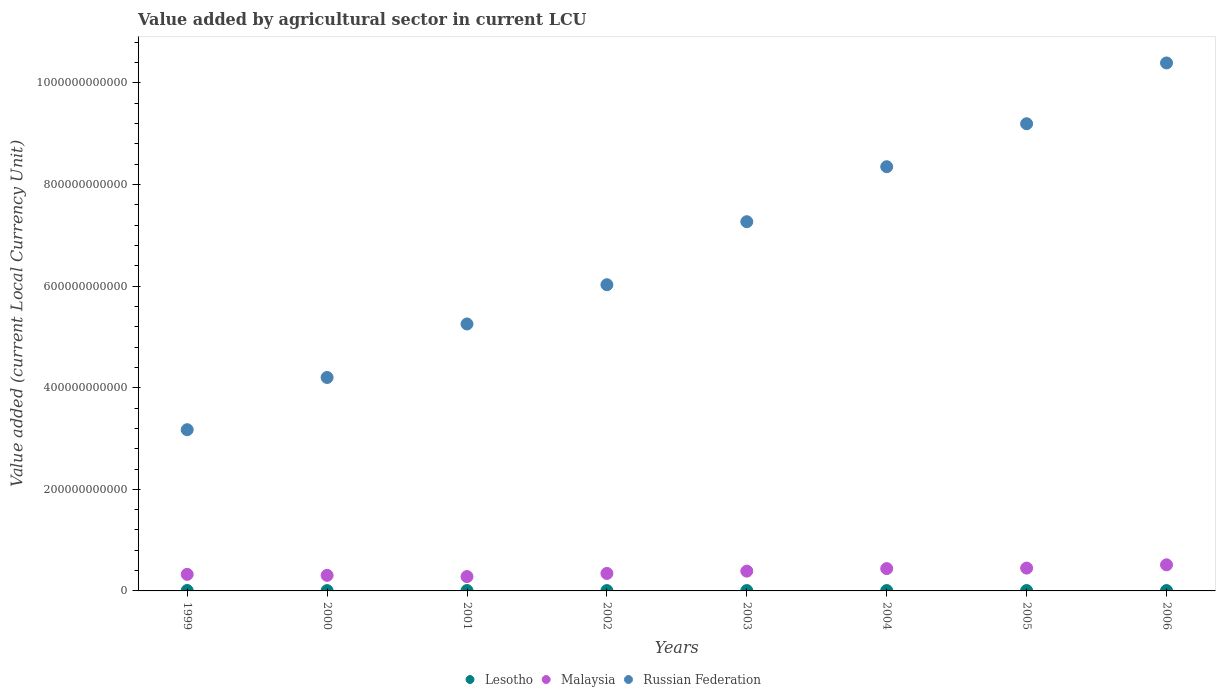Is the number of dotlines equal to the number of legend labels?
Give a very brief answer. Yes. What is the value added by agricultural sector in Russian Federation in 2005?
Offer a very short reply. 9.20e+11. Across all years, what is the maximum value added by agricultural sector in Russian Federation?
Give a very brief answer. 1.04e+12. Across all years, what is the minimum value added by agricultural sector in Malaysia?
Your answer should be compact. 2.82e+1. In which year was the value added by agricultural sector in Russian Federation maximum?
Provide a short and direct response. 2006. In which year was the value added by agricultural sector in Russian Federation minimum?
Your answer should be compact. 1999. What is the total value added by agricultural sector in Lesotho in the graph?
Your answer should be very brief. 5.61e+09. What is the difference between the value added by agricultural sector in Russian Federation in 2002 and that in 2003?
Provide a short and direct response. -1.24e+11. What is the difference between the value added by agricultural sector in Malaysia in 2002 and the value added by agricultural sector in Russian Federation in 2003?
Offer a very short reply. -6.92e+11. What is the average value added by agricultural sector in Lesotho per year?
Your answer should be compact. 7.02e+08. In the year 2005, what is the difference between the value added by agricultural sector in Malaysia and value added by agricultural sector in Lesotho?
Ensure brevity in your answer.  4.42e+1. In how many years, is the value added by agricultural sector in Lesotho greater than 160000000000 LCU?
Make the answer very short. 0. What is the ratio of the value added by agricultural sector in Malaysia in 2004 to that in 2005?
Your response must be concise. 0.98. What is the difference between the highest and the second highest value added by agricultural sector in Malaysia?
Offer a terse response. 6.47e+09. What is the difference between the highest and the lowest value added by agricultural sector in Russian Federation?
Your response must be concise. 7.22e+11. Does the value added by agricultural sector in Russian Federation monotonically increase over the years?
Keep it short and to the point. Yes. Is the value added by agricultural sector in Malaysia strictly greater than the value added by agricultural sector in Russian Federation over the years?
Provide a succinct answer. No. What is the difference between two consecutive major ticks on the Y-axis?
Your answer should be very brief. 2.00e+11. Does the graph contain any zero values?
Give a very brief answer. No. How many legend labels are there?
Provide a short and direct response. 3. What is the title of the graph?
Your answer should be compact. Value added by agricultural sector in current LCU. Does "Austria" appear as one of the legend labels in the graph?
Your answer should be very brief. No. What is the label or title of the X-axis?
Make the answer very short. Years. What is the label or title of the Y-axis?
Provide a short and direct response. Value added (current Local Currency Unit). What is the Value added (current Local Currency Unit) in Lesotho in 1999?
Offer a very short reply. 8.32e+08. What is the Value added (current Local Currency Unit) in Malaysia in 1999?
Provide a succinct answer. 3.26e+1. What is the Value added (current Local Currency Unit) of Russian Federation in 1999?
Make the answer very short. 3.17e+11. What is the Value added (current Local Currency Unit) in Lesotho in 2000?
Provide a short and direct response. 5.98e+08. What is the Value added (current Local Currency Unit) in Malaysia in 2000?
Make the answer very short. 3.06e+1. What is the Value added (current Local Currency Unit) of Russian Federation in 2000?
Offer a very short reply. 4.20e+11. What is the Value added (current Local Currency Unit) in Lesotho in 2001?
Give a very brief answer. 7.31e+08. What is the Value added (current Local Currency Unit) in Malaysia in 2001?
Keep it short and to the point. 2.82e+1. What is the Value added (current Local Currency Unit) of Russian Federation in 2001?
Ensure brevity in your answer.  5.26e+11. What is the Value added (current Local Currency Unit) of Lesotho in 2002?
Your response must be concise. 6.50e+08. What is the Value added (current Local Currency Unit) of Malaysia in 2002?
Your response must be concise. 3.44e+1. What is the Value added (current Local Currency Unit) of Russian Federation in 2002?
Offer a terse response. 6.03e+11. What is the Value added (current Local Currency Unit) of Lesotho in 2003?
Make the answer very short. 6.71e+08. What is the Value added (current Local Currency Unit) in Malaysia in 2003?
Give a very brief answer. 3.90e+1. What is the Value added (current Local Currency Unit) of Russian Federation in 2003?
Your response must be concise. 7.27e+11. What is the Value added (current Local Currency Unit) in Lesotho in 2004?
Keep it short and to the point. 7.02e+08. What is the Value added (current Local Currency Unit) of Malaysia in 2004?
Offer a terse response. 4.40e+1. What is the Value added (current Local Currency Unit) of Russian Federation in 2004?
Your answer should be very brief. 8.35e+11. What is the Value added (current Local Currency Unit) of Lesotho in 2005?
Provide a succinct answer. 7.21e+08. What is the Value added (current Local Currency Unit) in Malaysia in 2005?
Your answer should be very brief. 4.49e+1. What is the Value added (current Local Currency Unit) in Russian Federation in 2005?
Your answer should be compact. 9.20e+11. What is the Value added (current Local Currency Unit) of Lesotho in 2006?
Ensure brevity in your answer.  7.09e+08. What is the Value added (current Local Currency Unit) in Malaysia in 2006?
Give a very brief answer. 5.14e+1. What is the Value added (current Local Currency Unit) of Russian Federation in 2006?
Keep it short and to the point. 1.04e+12. Across all years, what is the maximum Value added (current Local Currency Unit) in Lesotho?
Give a very brief answer. 8.32e+08. Across all years, what is the maximum Value added (current Local Currency Unit) of Malaysia?
Make the answer very short. 5.14e+1. Across all years, what is the maximum Value added (current Local Currency Unit) in Russian Federation?
Provide a succinct answer. 1.04e+12. Across all years, what is the minimum Value added (current Local Currency Unit) of Lesotho?
Your response must be concise. 5.98e+08. Across all years, what is the minimum Value added (current Local Currency Unit) of Malaysia?
Keep it short and to the point. 2.82e+1. Across all years, what is the minimum Value added (current Local Currency Unit) of Russian Federation?
Provide a succinct answer. 3.17e+11. What is the total Value added (current Local Currency Unit) of Lesotho in the graph?
Your answer should be compact. 5.61e+09. What is the total Value added (current Local Currency Unit) in Malaysia in the graph?
Provide a short and direct response. 3.05e+11. What is the total Value added (current Local Currency Unit) of Russian Federation in the graph?
Provide a succinct answer. 5.39e+12. What is the difference between the Value added (current Local Currency Unit) in Lesotho in 1999 and that in 2000?
Your answer should be compact. 2.34e+08. What is the difference between the Value added (current Local Currency Unit) in Malaysia in 1999 and that in 2000?
Offer a very short reply. 1.96e+09. What is the difference between the Value added (current Local Currency Unit) in Russian Federation in 1999 and that in 2000?
Your response must be concise. -1.03e+11. What is the difference between the Value added (current Local Currency Unit) of Lesotho in 1999 and that in 2001?
Your answer should be very brief. 1.01e+08. What is the difference between the Value added (current Local Currency Unit) in Malaysia in 1999 and that in 2001?
Your answer should be compact. 4.36e+09. What is the difference between the Value added (current Local Currency Unit) of Russian Federation in 1999 and that in 2001?
Your response must be concise. -2.08e+11. What is the difference between the Value added (current Local Currency Unit) of Lesotho in 1999 and that in 2002?
Provide a succinct answer. 1.82e+08. What is the difference between the Value added (current Local Currency Unit) in Malaysia in 1999 and that in 2002?
Keep it short and to the point. -1.82e+09. What is the difference between the Value added (current Local Currency Unit) of Russian Federation in 1999 and that in 2002?
Your response must be concise. -2.85e+11. What is the difference between the Value added (current Local Currency Unit) in Lesotho in 1999 and that in 2003?
Keep it short and to the point. 1.61e+08. What is the difference between the Value added (current Local Currency Unit) in Malaysia in 1999 and that in 2003?
Give a very brief answer. -6.36e+09. What is the difference between the Value added (current Local Currency Unit) in Russian Federation in 1999 and that in 2003?
Provide a short and direct response. -4.09e+11. What is the difference between the Value added (current Local Currency Unit) of Lesotho in 1999 and that in 2004?
Your answer should be compact. 1.30e+08. What is the difference between the Value added (current Local Currency Unit) of Malaysia in 1999 and that in 2004?
Your response must be concise. -1.13e+1. What is the difference between the Value added (current Local Currency Unit) of Russian Federation in 1999 and that in 2004?
Keep it short and to the point. -5.18e+11. What is the difference between the Value added (current Local Currency Unit) of Lesotho in 1999 and that in 2005?
Make the answer very short. 1.11e+08. What is the difference between the Value added (current Local Currency Unit) of Malaysia in 1999 and that in 2005?
Provide a short and direct response. -1.23e+1. What is the difference between the Value added (current Local Currency Unit) in Russian Federation in 1999 and that in 2005?
Your answer should be compact. -6.02e+11. What is the difference between the Value added (current Local Currency Unit) of Lesotho in 1999 and that in 2006?
Offer a very short reply. 1.23e+08. What is the difference between the Value added (current Local Currency Unit) in Malaysia in 1999 and that in 2006?
Your answer should be compact. -1.88e+1. What is the difference between the Value added (current Local Currency Unit) of Russian Federation in 1999 and that in 2006?
Provide a succinct answer. -7.22e+11. What is the difference between the Value added (current Local Currency Unit) in Lesotho in 2000 and that in 2001?
Give a very brief answer. -1.33e+08. What is the difference between the Value added (current Local Currency Unit) in Malaysia in 2000 and that in 2001?
Provide a succinct answer. 2.40e+09. What is the difference between the Value added (current Local Currency Unit) in Russian Federation in 2000 and that in 2001?
Your answer should be very brief. -1.05e+11. What is the difference between the Value added (current Local Currency Unit) in Lesotho in 2000 and that in 2002?
Offer a terse response. -5.16e+07. What is the difference between the Value added (current Local Currency Unit) in Malaysia in 2000 and that in 2002?
Provide a short and direct response. -3.78e+09. What is the difference between the Value added (current Local Currency Unit) of Russian Federation in 2000 and that in 2002?
Keep it short and to the point. -1.83e+11. What is the difference between the Value added (current Local Currency Unit) of Lesotho in 2000 and that in 2003?
Give a very brief answer. -7.26e+07. What is the difference between the Value added (current Local Currency Unit) in Malaysia in 2000 and that in 2003?
Keep it short and to the point. -8.32e+09. What is the difference between the Value added (current Local Currency Unit) in Russian Federation in 2000 and that in 2003?
Offer a terse response. -3.07e+11. What is the difference between the Value added (current Local Currency Unit) in Lesotho in 2000 and that in 2004?
Your response must be concise. -1.04e+08. What is the difference between the Value added (current Local Currency Unit) of Malaysia in 2000 and that in 2004?
Provide a short and direct response. -1.33e+1. What is the difference between the Value added (current Local Currency Unit) of Russian Federation in 2000 and that in 2004?
Ensure brevity in your answer.  -4.15e+11. What is the difference between the Value added (current Local Currency Unit) in Lesotho in 2000 and that in 2005?
Offer a very short reply. -1.23e+08. What is the difference between the Value added (current Local Currency Unit) in Malaysia in 2000 and that in 2005?
Give a very brief answer. -1.43e+1. What is the difference between the Value added (current Local Currency Unit) in Russian Federation in 2000 and that in 2005?
Keep it short and to the point. -4.99e+11. What is the difference between the Value added (current Local Currency Unit) in Lesotho in 2000 and that in 2006?
Your answer should be compact. -1.10e+08. What is the difference between the Value added (current Local Currency Unit) of Malaysia in 2000 and that in 2006?
Ensure brevity in your answer.  -2.07e+1. What is the difference between the Value added (current Local Currency Unit) in Russian Federation in 2000 and that in 2006?
Offer a very short reply. -6.19e+11. What is the difference between the Value added (current Local Currency Unit) in Lesotho in 2001 and that in 2002?
Your response must be concise. 8.10e+07. What is the difference between the Value added (current Local Currency Unit) in Malaysia in 2001 and that in 2002?
Make the answer very short. -6.19e+09. What is the difference between the Value added (current Local Currency Unit) in Russian Federation in 2001 and that in 2002?
Keep it short and to the point. -7.73e+1. What is the difference between the Value added (current Local Currency Unit) in Lesotho in 2001 and that in 2003?
Ensure brevity in your answer.  6.00e+07. What is the difference between the Value added (current Local Currency Unit) of Malaysia in 2001 and that in 2003?
Your response must be concise. -1.07e+1. What is the difference between the Value added (current Local Currency Unit) of Russian Federation in 2001 and that in 2003?
Your answer should be very brief. -2.01e+11. What is the difference between the Value added (current Local Currency Unit) in Lesotho in 2001 and that in 2004?
Provide a short and direct response. 2.90e+07. What is the difference between the Value added (current Local Currency Unit) of Malaysia in 2001 and that in 2004?
Your response must be concise. -1.57e+1. What is the difference between the Value added (current Local Currency Unit) of Russian Federation in 2001 and that in 2004?
Keep it short and to the point. -3.10e+11. What is the difference between the Value added (current Local Currency Unit) in Lesotho in 2001 and that in 2005?
Keep it short and to the point. 9.99e+06. What is the difference between the Value added (current Local Currency Unit) in Malaysia in 2001 and that in 2005?
Provide a short and direct response. -1.67e+1. What is the difference between the Value added (current Local Currency Unit) of Russian Federation in 2001 and that in 2005?
Keep it short and to the point. -3.94e+11. What is the difference between the Value added (current Local Currency Unit) of Lesotho in 2001 and that in 2006?
Give a very brief answer. 2.23e+07. What is the difference between the Value added (current Local Currency Unit) in Malaysia in 2001 and that in 2006?
Your answer should be compact. -2.31e+1. What is the difference between the Value added (current Local Currency Unit) in Russian Federation in 2001 and that in 2006?
Offer a very short reply. -5.14e+11. What is the difference between the Value added (current Local Currency Unit) in Lesotho in 2002 and that in 2003?
Provide a short and direct response. -2.10e+07. What is the difference between the Value added (current Local Currency Unit) in Malaysia in 2002 and that in 2003?
Your answer should be very brief. -4.54e+09. What is the difference between the Value added (current Local Currency Unit) of Russian Federation in 2002 and that in 2003?
Provide a succinct answer. -1.24e+11. What is the difference between the Value added (current Local Currency Unit) in Lesotho in 2002 and that in 2004?
Offer a very short reply. -5.20e+07. What is the difference between the Value added (current Local Currency Unit) of Malaysia in 2002 and that in 2004?
Provide a short and direct response. -9.52e+09. What is the difference between the Value added (current Local Currency Unit) of Russian Federation in 2002 and that in 2004?
Ensure brevity in your answer.  -2.32e+11. What is the difference between the Value added (current Local Currency Unit) in Lesotho in 2002 and that in 2005?
Make the answer very short. -7.10e+07. What is the difference between the Value added (current Local Currency Unit) of Malaysia in 2002 and that in 2005?
Your answer should be compact. -1.05e+1. What is the difference between the Value added (current Local Currency Unit) in Russian Federation in 2002 and that in 2005?
Give a very brief answer. -3.17e+11. What is the difference between the Value added (current Local Currency Unit) in Lesotho in 2002 and that in 2006?
Provide a short and direct response. -5.87e+07. What is the difference between the Value added (current Local Currency Unit) of Malaysia in 2002 and that in 2006?
Give a very brief answer. -1.70e+1. What is the difference between the Value added (current Local Currency Unit) in Russian Federation in 2002 and that in 2006?
Offer a very short reply. -4.37e+11. What is the difference between the Value added (current Local Currency Unit) in Lesotho in 2003 and that in 2004?
Offer a terse response. -3.10e+07. What is the difference between the Value added (current Local Currency Unit) in Malaysia in 2003 and that in 2004?
Keep it short and to the point. -4.98e+09. What is the difference between the Value added (current Local Currency Unit) of Russian Federation in 2003 and that in 2004?
Provide a succinct answer. -1.08e+11. What is the difference between the Value added (current Local Currency Unit) in Lesotho in 2003 and that in 2005?
Provide a short and direct response. -5.00e+07. What is the difference between the Value added (current Local Currency Unit) in Malaysia in 2003 and that in 2005?
Offer a terse response. -5.94e+09. What is the difference between the Value added (current Local Currency Unit) in Russian Federation in 2003 and that in 2005?
Offer a very short reply. -1.93e+11. What is the difference between the Value added (current Local Currency Unit) of Lesotho in 2003 and that in 2006?
Your answer should be very brief. -3.77e+07. What is the difference between the Value added (current Local Currency Unit) in Malaysia in 2003 and that in 2006?
Offer a terse response. -1.24e+1. What is the difference between the Value added (current Local Currency Unit) in Russian Federation in 2003 and that in 2006?
Provide a succinct answer. -3.13e+11. What is the difference between the Value added (current Local Currency Unit) in Lesotho in 2004 and that in 2005?
Keep it short and to the point. -1.90e+07. What is the difference between the Value added (current Local Currency Unit) of Malaysia in 2004 and that in 2005?
Give a very brief answer. -9.62e+08. What is the difference between the Value added (current Local Currency Unit) in Russian Federation in 2004 and that in 2005?
Give a very brief answer. -8.46e+1. What is the difference between the Value added (current Local Currency Unit) in Lesotho in 2004 and that in 2006?
Your answer should be very brief. -6.68e+06. What is the difference between the Value added (current Local Currency Unit) in Malaysia in 2004 and that in 2006?
Offer a very short reply. -7.43e+09. What is the difference between the Value added (current Local Currency Unit) in Russian Federation in 2004 and that in 2006?
Ensure brevity in your answer.  -2.04e+11. What is the difference between the Value added (current Local Currency Unit) in Lesotho in 2005 and that in 2006?
Make the answer very short. 1.23e+07. What is the difference between the Value added (current Local Currency Unit) in Malaysia in 2005 and that in 2006?
Offer a terse response. -6.47e+09. What is the difference between the Value added (current Local Currency Unit) in Russian Federation in 2005 and that in 2006?
Provide a succinct answer. -1.20e+11. What is the difference between the Value added (current Local Currency Unit) of Lesotho in 1999 and the Value added (current Local Currency Unit) of Malaysia in 2000?
Keep it short and to the point. -2.98e+1. What is the difference between the Value added (current Local Currency Unit) of Lesotho in 1999 and the Value added (current Local Currency Unit) of Russian Federation in 2000?
Make the answer very short. -4.19e+11. What is the difference between the Value added (current Local Currency Unit) of Malaysia in 1999 and the Value added (current Local Currency Unit) of Russian Federation in 2000?
Your answer should be compact. -3.88e+11. What is the difference between the Value added (current Local Currency Unit) in Lesotho in 1999 and the Value added (current Local Currency Unit) in Malaysia in 2001?
Ensure brevity in your answer.  -2.74e+1. What is the difference between the Value added (current Local Currency Unit) of Lesotho in 1999 and the Value added (current Local Currency Unit) of Russian Federation in 2001?
Your answer should be very brief. -5.25e+11. What is the difference between the Value added (current Local Currency Unit) in Malaysia in 1999 and the Value added (current Local Currency Unit) in Russian Federation in 2001?
Ensure brevity in your answer.  -4.93e+11. What is the difference between the Value added (current Local Currency Unit) of Lesotho in 1999 and the Value added (current Local Currency Unit) of Malaysia in 2002?
Offer a terse response. -3.36e+1. What is the difference between the Value added (current Local Currency Unit) of Lesotho in 1999 and the Value added (current Local Currency Unit) of Russian Federation in 2002?
Provide a short and direct response. -6.02e+11. What is the difference between the Value added (current Local Currency Unit) in Malaysia in 1999 and the Value added (current Local Currency Unit) in Russian Federation in 2002?
Keep it short and to the point. -5.70e+11. What is the difference between the Value added (current Local Currency Unit) of Lesotho in 1999 and the Value added (current Local Currency Unit) of Malaysia in 2003?
Keep it short and to the point. -3.81e+1. What is the difference between the Value added (current Local Currency Unit) of Lesotho in 1999 and the Value added (current Local Currency Unit) of Russian Federation in 2003?
Provide a short and direct response. -7.26e+11. What is the difference between the Value added (current Local Currency Unit) in Malaysia in 1999 and the Value added (current Local Currency Unit) in Russian Federation in 2003?
Your answer should be very brief. -6.94e+11. What is the difference between the Value added (current Local Currency Unit) of Lesotho in 1999 and the Value added (current Local Currency Unit) of Malaysia in 2004?
Provide a short and direct response. -4.31e+1. What is the difference between the Value added (current Local Currency Unit) of Lesotho in 1999 and the Value added (current Local Currency Unit) of Russian Federation in 2004?
Give a very brief answer. -8.34e+11. What is the difference between the Value added (current Local Currency Unit) of Malaysia in 1999 and the Value added (current Local Currency Unit) of Russian Federation in 2004?
Give a very brief answer. -8.02e+11. What is the difference between the Value added (current Local Currency Unit) in Lesotho in 1999 and the Value added (current Local Currency Unit) in Malaysia in 2005?
Keep it short and to the point. -4.41e+1. What is the difference between the Value added (current Local Currency Unit) of Lesotho in 1999 and the Value added (current Local Currency Unit) of Russian Federation in 2005?
Make the answer very short. -9.19e+11. What is the difference between the Value added (current Local Currency Unit) of Malaysia in 1999 and the Value added (current Local Currency Unit) of Russian Federation in 2005?
Provide a short and direct response. -8.87e+11. What is the difference between the Value added (current Local Currency Unit) in Lesotho in 1999 and the Value added (current Local Currency Unit) in Malaysia in 2006?
Offer a very short reply. -5.06e+1. What is the difference between the Value added (current Local Currency Unit) of Lesotho in 1999 and the Value added (current Local Currency Unit) of Russian Federation in 2006?
Your answer should be very brief. -1.04e+12. What is the difference between the Value added (current Local Currency Unit) in Malaysia in 1999 and the Value added (current Local Currency Unit) in Russian Federation in 2006?
Provide a short and direct response. -1.01e+12. What is the difference between the Value added (current Local Currency Unit) in Lesotho in 2000 and the Value added (current Local Currency Unit) in Malaysia in 2001?
Provide a succinct answer. -2.76e+1. What is the difference between the Value added (current Local Currency Unit) of Lesotho in 2000 and the Value added (current Local Currency Unit) of Russian Federation in 2001?
Ensure brevity in your answer.  -5.25e+11. What is the difference between the Value added (current Local Currency Unit) in Malaysia in 2000 and the Value added (current Local Currency Unit) in Russian Federation in 2001?
Your answer should be compact. -4.95e+11. What is the difference between the Value added (current Local Currency Unit) in Lesotho in 2000 and the Value added (current Local Currency Unit) in Malaysia in 2002?
Keep it short and to the point. -3.38e+1. What is the difference between the Value added (current Local Currency Unit) in Lesotho in 2000 and the Value added (current Local Currency Unit) in Russian Federation in 2002?
Provide a short and direct response. -6.02e+11. What is the difference between the Value added (current Local Currency Unit) of Malaysia in 2000 and the Value added (current Local Currency Unit) of Russian Federation in 2002?
Your answer should be very brief. -5.72e+11. What is the difference between the Value added (current Local Currency Unit) in Lesotho in 2000 and the Value added (current Local Currency Unit) in Malaysia in 2003?
Ensure brevity in your answer.  -3.84e+1. What is the difference between the Value added (current Local Currency Unit) in Lesotho in 2000 and the Value added (current Local Currency Unit) in Russian Federation in 2003?
Make the answer very short. -7.26e+11. What is the difference between the Value added (current Local Currency Unit) of Malaysia in 2000 and the Value added (current Local Currency Unit) of Russian Federation in 2003?
Keep it short and to the point. -6.96e+11. What is the difference between the Value added (current Local Currency Unit) of Lesotho in 2000 and the Value added (current Local Currency Unit) of Malaysia in 2004?
Give a very brief answer. -4.34e+1. What is the difference between the Value added (current Local Currency Unit) in Lesotho in 2000 and the Value added (current Local Currency Unit) in Russian Federation in 2004?
Provide a short and direct response. -8.34e+11. What is the difference between the Value added (current Local Currency Unit) in Malaysia in 2000 and the Value added (current Local Currency Unit) in Russian Federation in 2004?
Ensure brevity in your answer.  -8.04e+11. What is the difference between the Value added (current Local Currency Unit) in Lesotho in 2000 and the Value added (current Local Currency Unit) in Malaysia in 2005?
Provide a short and direct response. -4.43e+1. What is the difference between the Value added (current Local Currency Unit) in Lesotho in 2000 and the Value added (current Local Currency Unit) in Russian Federation in 2005?
Offer a terse response. -9.19e+11. What is the difference between the Value added (current Local Currency Unit) in Malaysia in 2000 and the Value added (current Local Currency Unit) in Russian Federation in 2005?
Provide a succinct answer. -8.89e+11. What is the difference between the Value added (current Local Currency Unit) of Lesotho in 2000 and the Value added (current Local Currency Unit) of Malaysia in 2006?
Provide a succinct answer. -5.08e+1. What is the difference between the Value added (current Local Currency Unit) of Lesotho in 2000 and the Value added (current Local Currency Unit) of Russian Federation in 2006?
Ensure brevity in your answer.  -1.04e+12. What is the difference between the Value added (current Local Currency Unit) of Malaysia in 2000 and the Value added (current Local Currency Unit) of Russian Federation in 2006?
Ensure brevity in your answer.  -1.01e+12. What is the difference between the Value added (current Local Currency Unit) of Lesotho in 2001 and the Value added (current Local Currency Unit) of Malaysia in 2002?
Offer a very short reply. -3.37e+1. What is the difference between the Value added (current Local Currency Unit) of Lesotho in 2001 and the Value added (current Local Currency Unit) of Russian Federation in 2002?
Your answer should be compact. -6.02e+11. What is the difference between the Value added (current Local Currency Unit) of Malaysia in 2001 and the Value added (current Local Currency Unit) of Russian Federation in 2002?
Offer a very short reply. -5.75e+11. What is the difference between the Value added (current Local Currency Unit) in Lesotho in 2001 and the Value added (current Local Currency Unit) in Malaysia in 2003?
Your answer should be very brief. -3.82e+1. What is the difference between the Value added (current Local Currency Unit) in Lesotho in 2001 and the Value added (current Local Currency Unit) in Russian Federation in 2003?
Give a very brief answer. -7.26e+11. What is the difference between the Value added (current Local Currency Unit) of Malaysia in 2001 and the Value added (current Local Currency Unit) of Russian Federation in 2003?
Provide a short and direct response. -6.99e+11. What is the difference between the Value added (current Local Currency Unit) of Lesotho in 2001 and the Value added (current Local Currency Unit) of Malaysia in 2004?
Ensure brevity in your answer.  -4.32e+1. What is the difference between the Value added (current Local Currency Unit) in Lesotho in 2001 and the Value added (current Local Currency Unit) in Russian Federation in 2004?
Ensure brevity in your answer.  -8.34e+11. What is the difference between the Value added (current Local Currency Unit) in Malaysia in 2001 and the Value added (current Local Currency Unit) in Russian Federation in 2004?
Your response must be concise. -8.07e+11. What is the difference between the Value added (current Local Currency Unit) in Lesotho in 2001 and the Value added (current Local Currency Unit) in Malaysia in 2005?
Provide a short and direct response. -4.42e+1. What is the difference between the Value added (current Local Currency Unit) in Lesotho in 2001 and the Value added (current Local Currency Unit) in Russian Federation in 2005?
Make the answer very short. -9.19e+11. What is the difference between the Value added (current Local Currency Unit) in Malaysia in 2001 and the Value added (current Local Currency Unit) in Russian Federation in 2005?
Your answer should be very brief. -8.91e+11. What is the difference between the Value added (current Local Currency Unit) in Lesotho in 2001 and the Value added (current Local Currency Unit) in Malaysia in 2006?
Offer a terse response. -5.07e+1. What is the difference between the Value added (current Local Currency Unit) of Lesotho in 2001 and the Value added (current Local Currency Unit) of Russian Federation in 2006?
Provide a succinct answer. -1.04e+12. What is the difference between the Value added (current Local Currency Unit) of Malaysia in 2001 and the Value added (current Local Currency Unit) of Russian Federation in 2006?
Offer a very short reply. -1.01e+12. What is the difference between the Value added (current Local Currency Unit) in Lesotho in 2002 and the Value added (current Local Currency Unit) in Malaysia in 2003?
Offer a terse response. -3.83e+1. What is the difference between the Value added (current Local Currency Unit) of Lesotho in 2002 and the Value added (current Local Currency Unit) of Russian Federation in 2003?
Give a very brief answer. -7.26e+11. What is the difference between the Value added (current Local Currency Unit) in Malaysia in 2002 and the Value added (current Local Currency Unit) in Russian Federation in 2003?
Your answer should be very brief. -6.92e+11. What is the difference between the Value added (current Local Currency Unit) of Lesotho in 2002 and the Value added (current Local Currency Unit) of Malaysia in 2004?
Provide a succinct answer. -4.33e+1. What is the difference between the Value added (current Local Currency Unit) of Lesotho in 2002 and the Value added (current Local Currency Unit) of Russian Federation in 2004?
Provide a succinct answer. -8.34e+11. What is the difference between the Value added (current Local Currency Unit) of Malaysia in 2002 and the Value added (current Local Currency Unit) of Russian Federation in 2004?
Give a very brief answer. -8.01e+11. What is the difference between the Value added (current Local Currency Unit) in Lesotho in 2002 and the Value added (current Local Currency Unit) in Malaysia in 2005?
Your answer should be very brief. -4.43e+1. What is the difference between the Value added (current Local Currency Unit) in Lesotho in 2002 and the Value added (current Local Currency Unit) in Russian Federation in 2005?
Give a very brief answer. -9.19e+11. What is the difference between the Value added (current Local Currency Unit) of Malaysia in 2002 and the Value added (current Local Currency Unit) of Russian Federation in 2005?
Make the answer very short. -8.85e+11. What is the difference between the Value added (current Local Currency Unit) of Lesotho in 2002 and the Value added (current Local Currency Unit) of Malaysia in 2006?
Make the answer very short. -5.07e+1. What is the difference between the Value added (current Local Currency Unit) in Lesotho in 2002 and the Value added (current Local Currency Unit) in Russian Federation in 2006?
Your answer should be compact. -1.04e+12. What is the difference between the Value added (current Local Currency Unit) in Malaysia in 2002 and the Value added (current Local Currency Unit) in Russian Federation in 2006?
Offer a terse response. -1.00e+12. What is the difference between the Value added (current Local Currency Unit) in Lesotho in 2003 and the Value added (current Local Currency Unit) in Malaysia in 2004?
Provide a succinct answer. -4.33e+1. What is the difference between the Value added (current Local Currency Unit) in Lesotho in 2003 and the Value added (current Local Currency Unit) in Russian Federation in 2004?
Offer a terse response. -8.34e+11. What is the difference between the Value added (current Local Currency Unit) in Malaysia in 2003 and the Value added (current Local Currency Unit) in Russian Federation in 2004?
Keep it short and to the point. -7.96e+11. What is the difference between the Value added (current Local Currency Unit) in Lesotho in 2003 and the Value added (current Local Currency Unit) in Malaysia in 2005?
Your answer should be very brief. -4.42e+1. What is the difference between the Value added (current Local Currency Unit) in Lesotho in 2003 and the Value added (current Local Currency Unit) in Russian Federation in 2005?
Provide a succinct answer. -9.19e+11. What is the difference between the Value added (current Local Currency Unit) in Malaysia in 2003 and the Value added (current Local Currency Unit) in Russian Federation in 2005?
Provide a short and direct response. -8.81e+11. What is the difference between the Value added (current Local Currency Unit) of Lesotho in 2003 and the Value added (current Local Currency Unit) of Malaysia in 2006?
Your response must be concise. -5.07e+1. What is the difference between the Value added (current Local Currency Unit) in Lesotho in 2003 and the Value added (current Local Currency Unit) in Russian Federation in 2006?
Provide a short and direct response. -1.04e+12. What is the difference between the Value added (current Local Currency Unit) in Malaysia in 2003 and the Value added (current Local Currency Unit) in Russian Federation in 2006?
Offer a very short reply. -1.00e+12. What is the difference between the Value added (current Local Currency Unit) of Lesotho in 2004 and the Value added (current Local Currency Unit) of Malaysia in 2005?
Your response must be concise. -4.42e+1. What is the difference between the Value added (current Local Currency Unit) in Lesotho in 2004 and the Value added (current Local Currency Unit) in Russian Federation in 2005?
Provide a short and direct response. -9.19e+11. What is the difference between the Value added (current Local Currency Unit) of Malaysia in 2004 and the Value added (current Local Currency Unit) of Russian Federation in 2005?
Offer a terse response. -8.76e+11. What is the difference between the Value added (current Local Currency Unit) of Lesotho in 2004 and the Value added (current Local Currency Unit) of Malaysia in 2006?
Keep it short and to the point. -5.07e+1. What is the difference between the Value added (current Local Currency Unit) of Lesotho in 2004 and the Value added (current Local Currency Unit) of Russian Federation in 2006?
Ensure brevity in your answer.  -1.04e+12. What is the difference between the Value added (current Local Currency Unit) of Malaysia in 2004 and the Value added (current Local Currency Unit) of Russian Federation in 2006?
Your response must be concise. -9.95e+11. What is the difference between the Value added (current Local Currency Unit) of Lesotho in 2005 and the Value added (current Local Currency Unit) of Malaysia in 2006?
Give a very brief answer. -5.07e+1. What is the difference between the Value added (current Local Currency Unit) of Lesotho in 2005 and the Value added (current Local Currency Unit) of Russian Federation in 2006?
Provide a succinct answer. -1.04e+12. What is the difference between the Value added (current Local Currency Unit) of Malaysia in 2005 and the Value added (current Local Currency Unit) of Russian Federation in 2006?
Your answer should be very brief. -9.94e+11. What is the average Value added (current Local Currency Unit) of Lesotho per year?
Keep it short and to the point. 7.02e+08. What is the average Value added (current Local Currency Unit) of Malaysia per year?
Give a very brief answer. 3.81e+1. What is the average Value added (current Local Currency Unit) in Russian Federation per year?
Your answer should be very brief. 6.73e+11. In the year 1999, what is the difference between the Value added (current Local Currency Unit) in Lesotho and Value added (current Local Currency Unit) in Malaysia?
Provide a succinct answer. -3.18e+1. In the year 1999, what is the difference between the Value added (current Local Currency Unit) in Lesotho and Value added (current Local Currency Unit) in Russian Federation?
Your answer should be compact. -3.17e+11. In the year 1999, what is the difference between the Value added (current Local Currency Unit) in Malaysia and Value added (current Local Currency Unit) in Russian Federation?
Ensure brevity in your answer.  -2.85e+11. In the year 2000, what is the difference between the Value added (current Local Currency Unit) of Lesotho and Value added (current Local Currency Unit) of Malaysia?
Your response must be concise. -3.00e+1. In the year 2000, what is the difference between the Value added (current Local Currency Unit) of Lesotho and Value added (current Local Currency Unit) of Russian Federation?
Provide a succinct answer. -4.20e+11. In the year 2000, what is the difference between the Value added (current Local Currency Unit) of Malaysia and Value added (current Local Currency Unit) of Russian Federation?
Offer a very short reply. -3.90e+11. In the year 2001, what is the difference between the Value added (current Local Currency Unit) in Lesotho and Value added (current Local Currency Unit) in Malaysia?
Provide a succinct answer. -2.75e+1. In the year 2001, what is the difference between the Value added (current Local Currency Unit) of Lesotho and Value added (current Local Currency Unit) of Russian Federation?
Make the answer very short. -5.25e+11. In the year 2001, what is the difference between the Value added (current Local Currency Unit) in Malaysia and Value added (current Local Currency Unit) in Russian Federation?
Your answer should be very brief. -4.97e+11. In the year 2002, what is the difference between the Value added (current Local Currency Unit) of Lesotho and Value added (current Local Currency Unit) of Malaysia?
Offer a terse response. -3.38e+1. In the year 2002, what is the difference between the Value added (current Local Currency Unit) in Lesotho and Value added (current Local Currency Unit) in Russian Federation?
Your answer should be compact. -6.02e+11. In the year 2002, what is the difference between the Value added (current Local Currency Unit) of Malaysia and Value added (current Local Currency Unit) of Russian Federation?
Your response must be concise. -5.68e+11. In the year 2003, what is the difference between the Value added (current Local Currency Unit) of Lesotho and Value added (current Local Currency Unit) of Malaysia?
Make the answer very short. -3.83e+1. In the year 2003, what is the difference between the Value added (current Local Currency Unit) in Lesotho and Value added (current Local Currency Unit) in Russian Federation?
Your response must be concise. -7.26e+11. In the year 2003, what is the difference between the Value added (current Local Currency Unit) in Malaysia and Value added (current Local Currency Unit) in Russian Federation?
Make the answer very short. -6.88e+11. In the year 2004, what is the difference between the Value added (current Local Currency Unit) in Lesotho and Value added (current Local Currency Unit) in Malaysia?
Offer a terse response. -4.32e+1. In the year 2004, what is the difference between the Value added (current Local Currency Unit) of Lesotho and Value added (current Local Currency Unit) of Russian Federation?
Keep it short and to the point. -8.34e+11. In the year 2004, what is the difference between the Value added (current Local Currency Unit) in Malaysia and Value added (current Local Currency Unit) in Russian Federation?
Offer a terse response. -7.91e+11. In the year 2005, what is the difference between the Value added (current Local Currency Unit) in Lesotho and Value added (current Local Currency Unit) in Malaysia?
Offer a very short reply. -4.42e+1. In the year 2005, what is the difference between the Value added (current Local Currency Unit) of Lesotho and Value added (current Local Currency Unit) of Russian Federation?
Your response must be concise. -9.19e+11. In the year 2005, what is the difference between the Value added (current Local Currency Unit) in Malaysia and Value added (current Local Currency Unit) in Russian Federation?
Your response must be concise. -8.75e+11. In the year 2006, what is the difference between the Value added (current Local Currency Unit) of Lesotho and Value added (current Local Currency Unit) of Malaysia?
Your response must be concise. -5.07e+1. In the year 2006, what is the difference between the Value added (current Local Currency Unit) in Lesotho and Value added (current Local Currency Unit) in Russian Federation?
Offer a very short reply. -1.04e+12. In the year 2006, what is the difference between the Value added (current Local Currency Unit) of Malaysia and Value added (current Local Currency Unit) of Russian Federation?
Offer a terse response. -9.88e+11. What is the ratio of the Value added (current Local Currency Unit) in Lesotho in 1999 to that in 2000?
Make the answer very short. 1.39. What is the ratio of the Value added (current Local Currency Unit) in Malaysia in 1999 to that in 2000?
Make the answer very short. 1.06. What is the ratio of the Value added (current Local Currency Unit) of Russian Federation in 1999 to that in 2000?
Keep it short and to the point. 0.76. What is the ratio of the Value added (current Local Currency Unit) in Lesotho in 1999 to that in 2001?
Your answer should be compact. 1.14. What is the ratio of the Value added (current Local Currency Unit) of Malaysia in 1999 to that in 2001?
Offer a very short reply. 1.15. What is the ratio of the Value added (current Local Currency Unit) in Russian Federation in 1999 to that in 2001?
Your answer should be compact. 0.6. What is the ratio of the Value added (current Local Currency Unit) of Lesotho in 1999 to that in 2002?
Your answer should be compact. 1.28. What is the ratio of the Value added (current Local Currency Unit) of Malaysia in 1999 to that in 2002?
Make the answer very short. 0.95. What is the ratio of the Value added (current Local Currency Unit) in Russian Federation in 1999 to that in 2002?
Provide a succinct answer. 0.53. What is the ratio of the Value added (current Local Currency Unit) of Lesotho in 1999 to that in 2003?
Your answer should be very brief. 1.24. What is the ratio of the Value added (current Local Currency Unit) in Malaysia in 1999 to that in 2003?
Offer a very short reply. 0.84. What is the ratio of the Value added (current Local Currency Unit) in Russian Federation in 1999 to that in 2003?
Provide a succinct answer. 0.44. What is the ratio of the Value added (current Local Currency Unit) of Lesotho in 1999 to that in 2004?
Ensure brevity in your answer.  1.19. What is the ratio of the Value added (current Local Currency Unit) of Malaysia in 1999 to that in 2004?
Provide a succinct answer. 0.74. What is the ratio of the Value added (current Local Currency Unit) in Russian Federation in 1999 to that in 2004?
Provide a short and direct response. 0.38. What is the ratio of the Value added (current Local Currency Unit) in Lesotho in 1999 to that in 2005?
Your answer should be very brief. 1.15. What is the ratio of the Value added (current Local Currency Unit) in Malaysia in 1999 to that in 2005?
Your answer should be compact. 0.73. What is the ratio of the Value added (current Local Currency Unit) of Russian Federation in 1999 to that in 2005?
Ensure brevity in your answer.  0.35. What is the ratio of the Value added (current Local Currency Unit) of Lesotho in 1999 to that in 2006?
Offer a very short reply. 1.17. What is the ratio of the Value added (current Local Currency Unit) of Malaysia in 1999 to that in 2006?
Provide a succinct answer. 0.63. What is the ratio of the Value added (current Local Currency Unit) in Russian Federation in 1999 to that in 2006?
Your answer should be very brief. 0.31. What is the ratio of the Value added (current Local Currency Unit) of Lesotho in 2000 to that in 2001?
Your answer should be very brief. 0.82. What is the ratio of the Value added (current Local Currency Unit) of Malaysia in 2000 to that in 2001?
Keep it short and to the point. 1.09. What is the ratio of the Value added (current Local Currency Unit) of Russian Federation in 2000 to that in 2001?
Your answer should be compact. 0.8. What is the ratio of the Value added (current Local Currency Unit) of Lesotho in 2000 to that in 2002?
Offer a very short reply. 0.92. What is the ratio of the Value added (current Local Currency Unit) in Malaysia in 2000 to that in 2002?
Keep it short and to the point. 0.89. What is the ratio of the Value added (current Local Currency Unit) of Russian Federation in 2000 to that in 2002?
Provide a succinct answer. 0.7. What is the ratio of the Value added (current Local Currency Unit) in Lesotho in 2000 to that in 2003?
Offer a terse response. 0.89. What is the ratio of the Value added (current Local Currency Unit) in Malaysia in 2000 to that in 2003?
Your answer should be compact. 0.79. What is the ratio of the Value added (current Local Currency Unit) of Russian Federation in 2000 to that in 2003?
Make the answer very short. 0.58. What is the ratio of the Value added (current Local Currency Unit) of Lesotho in 2000 to that in 2004?
Your answer should be compact. 0.85. What is the ratio of the Value added (current Local Currency Unit) in Malaysia in 2000 to that in 2004?
Give a very brief answer. 0.7. What is the ratio of the Value added (current Local Currency Unit) in Russian Federation in 2000 to that in 2004?
Provide a succinct answer. 0.5. What is the ratio of the Value added (current Local Currency Unit) in Lesotho in 2000 to that in 2005?
Your response must be concise. 0.83. What is the ratio of the Value added (current Local Currency Unit) of Malaysia in 2000 to that in 2005?
Provide a succinct answer. 0.68. What is the ratio of the Value added (current Local Currency Unit) in Russian Federation in 2000 to that in 2005?
Keep it short and to the point. 0.46. What is the ratio of the Value added (current Local Currency Unit) of Lesotho in 2000 to that in 2006?
Keep it short and to the point. 0.84. What is the ratio of the Value added (current Local Currency Unit) in Malaysia in 2000 to that in 2006?
Offer a terse response. 0.6. What is the ratio of the Value added (current Local Currency Unit) of Russian Federation in 2000 to that in 2006?
Your response must be concise. 0.4. What is the ratio of the Value added (current Local Currency Unit) of Lesotho in 2001 to that in 2002?
Give a very brief answer. 1.12. What is the ratio of the Value added (current Local Currency Unit) in Malaysia in 2001 to that in 2002?
Your answer should be compact. 0.82. What is the ratio of the Value added (current Local Currency Unit) of Russian Federation in 2001 to that in 2002?
Ensure brevity in your answer.  0.87. What is the ratio of the Value added (current Local Currency Unit) of Lesotho in 2001 to that in 2003?
Make the answer very short. 1.09. What is the ratio of the Value added (current Local Currency Unit) of Malaysia in 2001 to that in 2003?
Your answer should be compact. 0.72. What is the ratio of the Value added (current Local Currency Unit) of Russian Federation in 2001 to that in 2003?
Provide a succinct answer. 0.72. What is the ratio of the Value added (current Local Currency Unit) in Lesotho in 2001 to that in 2004?
Offer a terse response. 1.04. What is the ratio of the Value added (current Local Currency Unit) in Malaysia in 2001 to that in 2004?
Your answer should be very brief. 0.64. What is the ratio of the Value added (current Local Currency Unit) of Russian Federation in 2001 to that in 2004?
Give a very brief answer. 0.63. What is the ratio of the Value added (current Local Currency Unit) in Lesotho in 2001 to that in 2005?
Offer a very short reply. 1.01. What is the ratio of the Value added (current Local Currency Unit) in Malaysia in 2001 to that in 2005?
Your response must be concise. 0.63. What is the ratio of the Value added (current Local Currency Unit) in Lesotho in 2001 to that in 2006?
Offer a very short reply. 1.03. What is the ratio of the Value added (current Local Currency Unit) of Malaysia in 2001 to that in 2006?
Your answer should be compact. 0.55. What is the ratio of the Value added (current Local Currency Unit) of Russian Federation in 2001 to that in 2006?
Provide a succinct answer. 0.51. What is the ratio of the Value added (current Local Currency Unit) in Lesotho in 2002 to that in 2003?
Offer a very short reply. 0.97. What is the ratio of the Value added (current Local Currency Unit) of Malaysia in 2002 to that in 2003?
Provide a short and direct response. 0.88. What is the ratio of the Value added (current Local Currency Unit) of Russian Federation in 2002 to that in 2003?
Your response must be concise. 0.83. What is the ratio of the Value added (current Local Currency Unit) in Lesotho in 2002 to that in 2004?
Your answer should be compact. 0.93. What is the ratio of the Value added (current Local Currency Unit) in Malaysia in 2002 to that in 2004?
Your answer should be very brief. 0.78. What is the ratio of the Value added (current Local Currency Unit) in Russian Federation in 2002 to that in 2004?
Ensure brevity in your answer.  0.72. What is the ratio of the Value added (current Local Currency Unit) of Lesotho in 2002 to that in 2005?
Your answer should be very brief. 0.9. What is the ratio of the Value added (current Local Currency Unit) in Malaysia in 2002 to that in 2005?
Your response must be concise. 0.77. What is the ratio of the Value added (current Local Currency Unit) in Russian Federation in 2002 to that in 2005?
Provide a short and direct response. 0.66. What is the ratio of the Value added (current Local Currency Unit) of Lesotho in 2002 to that in 2006?
Your answer should be compact. 0.92. What is the ratio of the Value added (current Local Currency Unit) of Malaysia in 2002 to that in 2006?
Your answer should be very brief. 0.67. What is the ratio of the Value added (current Local Currency Unit) in Russian Federation in 2002 to that in 2006?
Offer a very short reply. 0.58. What is the ratio of the Value added (current Local Currency Unit) in Lesotho in 2003 to that in 2004?
Your answer should be very brief. 0.96. What is the ratio of the Value added (current Local Currency Unit) of Malaysia in 2003 to that in 2004?
Make the answer very short. 0.89. What is the ratio of the Value added (current Local Currency Unit) of Russian Federation in 2003 to that in 2004?
Keep it short and to the point. 0.87. What is the ratio of the Value added (current Local Currency Unit) of Lesotho in 2003 to that in 2005?
Your answer should be compact. 0.93. What is the ratio of the Value added (current Local Currency Unit) of Malaysia in 2003 to that in 2005?
Your answer should be compact. 0.87. What is the ratio of the Value added (current Local Currency Unit) of Russian Federation in 2003 to that in 2005?
Provide a short and direct response. 0.79. What is the ratio of the Value added (current Local Currency Unit) of Lesotho in 2003 to that in 2006?
Your answer should be very brief. 0.95. What is the ratio of the Value added (current Local Currency Unit) in Malaysia in 2003 to that in 2006?
Your answer should be very brief. 0.76. What is the ratio of the Value added (current Local Currency Unit) in Russian Federation in 2003 to that in 2006?
Provide a succinct answer. 0.7. What is the ratio of the Value added (current Local Currency Unit) in Lesotho in 2004 to that in 2005?
Provide a short and direct response. 0.97. What is the ratio of the Value added (current Local Currency Unit) of Malaysia in 2004 to that in 2005?
Your answer should be very brief. 0.98. What is the ratio of the Value added (current Local Currency Unit) of Russian Federation in 2004 to that in 2005?
Give a very brief answer. 0.91. What is the ratio of the Value added (current Local Currency Unit) of Lesotho in 2004 to that in 2006?
Your answer should be very brief. 0.99. What is the ratio of the Value added (current Local Currency Unit) in Malaysia in 2004 to that in 2006?
Your response must be concise. 0.86. What is the ratio of the Value added (current Local Currency Unit) of Russian Federation in 2004 to that in 2006?
Offer a very short reply. 0.8. What is the ratio of the Value added (current Local Currency Unit) of Lesotho in 2005 to that in 2006?
Make the answer very short. 1.02. What is the ratio of the Value added (current Local Currency Unit) in Malaysia in 2005 to that in 2006?
Your answer should be compact. 0.87. What is the ratio of the Value added (current Local Currency Unit) in Russian Federation in 2005 to that in 2006?
Provide a short and direct response. 0.88. What is the difference between the highest and the second highest Value added (current Local Currency Unit) in Lesotho?
Provide a short and direct response. 1.01e+08. What is the difference between the highest and the second highest Value added (current Local Currency Unit) in Malaysia?
Ensure brevity in your answer.  6.47e+09. What is the difference between the highest and the second highest Value added (current Local Currency Unit) in Russian Federation?
Provide a short and direct response. 1.20e+11. What is the difference between the highest and the lowest Value added (current Local Currency Unit) in Lesotho?
Provide a succinct answer. 2.34e+08. What is the difference between the highest and the lowest Value added (current Local Currency Unit) of Malaysia?
Offer a terse response. 2.31e+1. What is the difference between the highest and the lowest Value added (current Local Currency Unit) of Russian Federation?
Your response must be concise. 7.22e+11. 